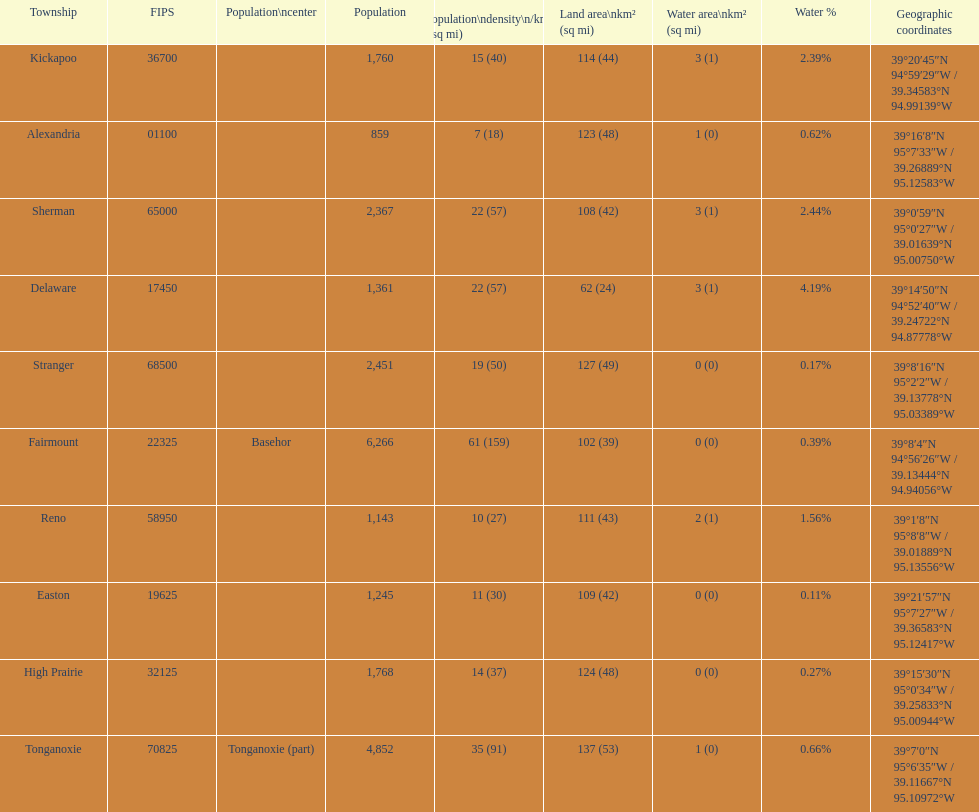Write the full table. {'header': ['Township', 'FIPS', 'Population\\ncenter', 'Population', 'Population\\ndensity\\n/km² (/sq\xa0mi)', 'Land area\\nkm² (sq\xa0mi)', 'Water area\\nkm² (sq\xa0mi)', 'Water\xa0%', 'Geographic coordinates'], 'rows': [['Kickapoo', '36700', '', '1,760', '15 (40)', '114 (44)', '3 (1)', '2.39%', '39°20′45″N 94°59′29″W\ufeff / \ufeff39.34583°N 94.99139°W'], ['Alexandria', '01100', '', '859', '7 (18)', '123 (48)', '1 (0)', '0.62%', '39°16′8″N 95°7′33″W\ufeff / \ufeff39.26889°N 95.12583°W'], ['Sherman', '65000', '', '2,367', '22 (57)', '108 (42)', '3 (1)', '2.44%', '39°0′59″N 95°0′27″W\ufeff / \ufeff39.01639°N 95.00750°W'], ['Delaware', '17450', '', '1,361', '22 (57)', '62 (24)', '3 (1)', '4.19%', '39°14′50″N 94°52′40″W\ufeff / \ufeff39.24722°N 94.87778°W'], ['Stranger', '68500', '', '2,451', '19 (50)', '127 (49)', '0 (0)', '0.17%', '39°8′16″N 95°2′2″W\ufeff / \ufeff39.13778°N 95.03389°W'], ['Fairmount', '22325', 'Basehor', '6,266', '61 (159)', '102 (39)', '0 (0)', '0.39%', '39°8′4″N 94°56′26″W\ufeff / \ufeff39.13444°N 94.94056°W'], ['Reno', '58950', '', '1,143', '10 (27)', '111 (43)', '2 (1)', '1.56%', '39°1′8″N 95°8′8″W\ufeff / \ufeff39.01889°N 95.13556°W'], ['Easton', '19625', '', '1,245', '11 (30)', '109 (42)', '0 (0)', '0.11%', '39°21′57″N 95°7′27″W\ufeff / \ufeff39.36583°N 95.12417°W'], ['High Prairie', '32125', '', '1,768', '14 (37)', '124 (48)', '0 (0)', '0.27%', '39°15′30″N 95°0′34″W\ufeff / \ufeff39.25833°N 95.00944°W'], ['Tonganoxie', '70825', 'Tonganoxie (part)', '4,852', '35 (91)', '137 (53)', '1 (0)', '0.66%', '39°7′0″N 95°6′35″W\ufeff / \ufeff39.11667°N 95.10972°W']]} What is the number of townships with a population larger than 2,000? 4. 